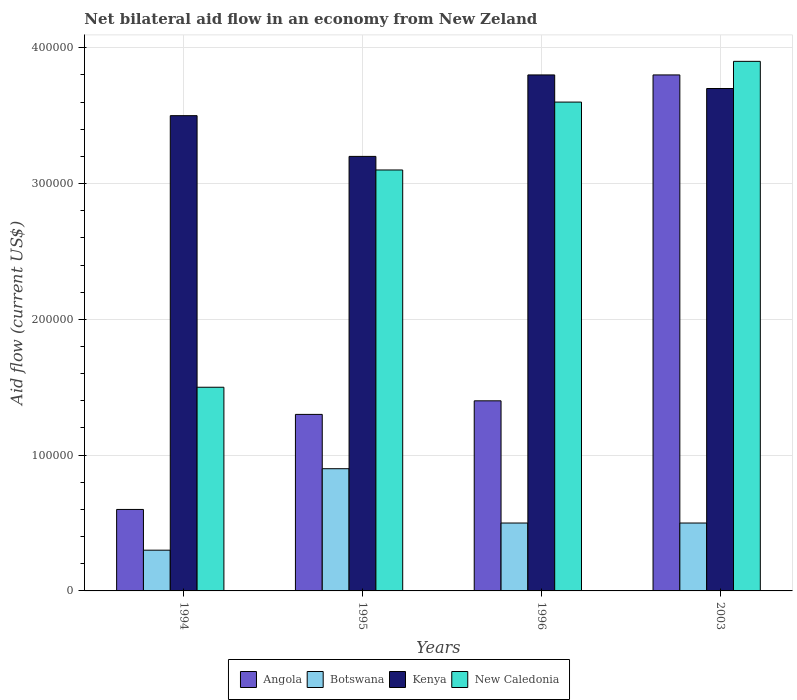How many different coloured bars are there?
Offer a very short reply. 4. What is the label of the 3rd group of bars from the left?
Keep it short and to the point. 1996. In how many cases, is the number of bars for a given year not equal to the number of legend labels?
Your response must be concise. 0. Across all years, what is the maximum net bilateral aid flow in New Caledonia?
Give a very brief answer. 3.90e+05. Across all years, what is the minimum net bilateral aid flow in Botswana?
Make the answer very short. 3.00e+04. In which year was the net bilateral aid flow in Kenya maximum?
Keep it short and to the point. 1996. In which year was the net bilateral aid flow in New Caledonia minimum?
Keep it short and to the point. 1994. What is the total net bilateral aid flow in Kenya in the graph?
Your answer should be compact. 1.42e+06. What is the average net bilateral aid flow in Botswana per year?
Offer a terse response. 5.50e+04. In the year 1996, what is the difference between the net bilateral aid flow in Botswana and net bilateral aid flow in Kenya?
Ensure brevity in your answer.  -3.30e+05. In how many years, is the net bilateral aid flow in Angola greater than 60000 US$?
Keep it short and to the point. 3. What is the ratio of the net bilateral aid flow in New Caledonia in 1994 to that in 2003?
Your answer should be very brief. 0.38. What is the difference between the highest and the second highest net bilateral aid flow in New Caledonia?
Your answer should be compact. 3.00e+04. What is the difference between the highest and the lowest net bilateral aid flow in Botswana?
Ensure brevity in your answer.  6.00e+04. Is it the case that in every year, the sum of the net bilateral aid flow in New Caledonia and net bilateral aid flow in Kenya is greater than the sum of net bilateral aid flow in Botswana and net bilateral aid flow in Angola?
Provide a short and direct response. No. What does the 3rd bar from the left in 1995 represents?
Provide a short and direct response. Kenya. What does the 1st bar from the right in 1996 represents?
Your response must be concise. New Caledonia. How many bars are there?
Your response must be concise. 16. How many years are there in the graph?
Your response must be concise. 4. What is the title of the graph?
Make the answer very short. Net bilateral aid flow in an economy from New Zeland. What is the label or title of the X-axis?
Ensure brevity in your answer.  Years. What is the Aid flow (current US$) in Botswana in 1994?
Make the answer very short. 3.00e+04. What is the Aid flow (current US$) in Angola in 1995?
Provide a short and direct response. 1.30e+05. What is the Aid flow (current US$) in Kenya in 1995?
Your answer should be compact. 3.20e+05. What is the Aid flow (current US$) of New Caledonia in 1995?
Make the answer very short. 3.10e+05. What is the Aid flow (current US$) of Angola in 1996?
Your answer should be very brief. 1.40e+05. What is the Aid flow (current US$) in Botswana in 1996?
Your response must be concise. 5.00e+04. What is the Aid flow (current US$) of New Caledonia in 1996?
Provide a short and direct response. 3.60e+05. What is the Aid flow (current US$) in Angola in 2003?
Ensure brevity in your answer.  3.80e+05. What is the Aid flow (current US$) of Botswana in 2003?
Make the answer very short. 5.00e+04. Across all years, what is the maximum Aid flow (current US$) in Botswana?
Make the answer very short. 9.00e+04. Across all years, what is the maximum Aid flow (current US$) of Kenya?
Ensure brevity in your answer.  3.80e+05. Across all years, what is the maximum Aid flow (current US$) of New Caledonia?
Make the answer very short. 3.90e+05. Across all years, what is the minimum Aid flow (current US$) in Angola?
Offer a very short reply. 6.00e+04. Across all years, what is the minimum Aid flow (current US$) in Kenya?
Provide a succinct answer. 3.20e+05. Across all years, what is the minimum Aid flow (current US$) of New Caledonia?
Ensure brevity in your answer.  1.50e+05. What is the total Aid flow (current US$) of Angola in the graph?
Your answer should be compact. 7.10e+05. What is the total Aid flow (current US$) in Botswana in the graph?
Offer a terse response. 2.20e+05. What is the total Aid flow (current US$) in Kenya in the graph?
Your answer should be very brief. 1.42e+06. What is the total Aid flow (current US$) of New Caledonia in the graph?
Provide a short and direct response. 1.21e+06. What is the difference between the Aid flow (current US$) in Botswana in 1994 and that in 1995?
Offer a very short reply. -6.00e+04. What is the difference between the Aid flow (current US$) in Angola in 1994 and that in 1996?
Give a very brief answer. -8.00e+04. What is the difference between the Aid flow (current US$) of Botswana in 1994 and that in 1996?
Provide a short and direct response. -2.00e+04. What is the difference between the Aid flow (current US$) in Kenya in 1994 and that in 1996?
Provide a short and direct response. -3.00e+04. What is the difference between the Aid flow (current US$) in New Caledonia in 1994 and that in 1996?
Keep it short and to the point. -2.10e+05. What is the difference between the Aid flow (current US$) in Angola in 1994 and that in 2003?
Keep it short and to the point. -3.20e+05. What is the difference between the Aid flow (current US$) of New Caledonia in 1994 and that in 2003?
Make the answer very short. -2.40e+05. What is the difference between the Aid flow (current US$) of Angola in 1995 and that in 1996?
Give a very brief answer. -10000. What is the difference between the Aid flow (current US$) in Kenya in 1995 and that in 1996?
Provide a succinct answer. -6.00e+04. What is the difference between the Aid flow (current US$) in New Caledonia in 1995 and that in 1996?
Provide a succinct answer. -5.00e+04. What is the difference between the Aid flow (current US$) in Botswana in 1995 and that in 2003?
Give a very brief answer. 4.00e+04. What is the difference between the Aid flow (current US$) in Angola in 1996 and that in 2003?
Your response must be concise. -2.40e+05. What is the difference between the Aid flow (current US$) of Botswana in 1996 and that in 2003?
Offer a terse response. 0. What is the difference between the Aid flow (current US$) in Kenya in 1996 and that in 2003?
Keep it short and to the point. 10000. What is the difference between the Aid flow (current US$) of Angola in 1994 and the Aid flow (current US$) of Botswana in 1995?
Provide a short and direct response. -3.00e+04. What is the difference between the Aid flow (current US$) of Angola in 1994 and the Aid flow (current US$) of Kenya in 1995?
Offer a terse response. -2.60e+05. What is the difference between the Aid flow (current US$) of Angola in 1994 and the Aid flow (current US$) of New Caledonia in 1995?
Make the answer very short. -2.50e+05. What is the difference between the Aid flow (current US$) in Botswana in 1994 and the Aid flow (current US$) in Kenya in 1995?
Offer a very short reply. -2.90e+05. What is the difference between the Aid flow (current US$) of Botswana in 1994 and the Aid flow (current US$) of New Caledonia in 1995?
Ensure brevity in your answer.  -2.80e+05. What is the difference between the Aid flow (current US$) of Kenya in 1994 and the Aid flow (current US$) of New Caledonia in 1995?
Your answer should be compact. 4.00e+04. What is the difference between the Aid flow (current US$) in Angola in 1994 and the Aid flow (current US$) in Kenya in 1996?
Your answer should be compact. -3.20e+05. What is the difference between the Aid flow (current US$) of Botswana in 1994 and the Aid flow (current US$) of Kenya in 1996?
Ensure brevity in your answer.  -3.50e+05. What is the difference between the Aid flow (current US$) of Botswana in 1994 and the Aid flow (current US$) of New Caledonia in 1996?
Offer a terse response. -3.30e+05. What is the difference between the Aid flow (current US$) in Kenya in 1994 and the Aid flow (current US$) in New Caledonia in 1996?
Provide a short and direct response. -10000. What is the difference between the Aid flow (current US$) of Angola in 1994 and the Aid flow (current US$) of Kenya in 2003?
Ensure brevity in your answer.  -3.10e+05. What is the difference between the Aid flow (current US$) in Angola in 1994 and the Aid flow (current US$) in New Caledonia in 2003?
Keep it short and to the point. -3.30e+05. What is the difference between the Aid flow (current US$) of Botswana in 1994 and the Aid flow (current US$) of New Caledonia in 2003?
Provide a short and direct response. -3.60e+05. What is the difference between the Aid flow (current US$) of Angola in 1995 and the Aid flow (current US$) of Botswana in 1996?
Ensure brevity in your answer.  8.00e+04. What is the difference between the Aid flow (current US$) of Angola in 1995 and the Aid flow (current US$) of New Caledonia in 1996?
Give a very brief answer. -2.30e+05. What is the difference between the Aid flow (current US$) of Botswana in 1995 and the Aid flow (current US$) of Kenya in 1996?
Provide a short and direct response. -2.90e+05. What is the difference between the Aid flow (current US$) of Botswana in 1995 and the Aid flow (current US$) of New Caledonia in 1996?
Your answer should be very brief. -2.70e+05. What is the difference between the Aid flow (current US$) of Kenya in 1995 and the Aid flow (current US$) of New Caledonia in 1996?
Ensure brevity in your answer.  -4.00e+04. What is the difference between the Aid flow (current US$) in Angola in 1995 and the Aid flow (current US$) in Botswana in 2003?
Your answer should be very brief. 8.00e+04. What is the difference between the Aid flow (current US$) of Botswana in 1995 and the Aid flow (current US$) of Kenya in 2003?
Your response must be concise. -2.80e+05. What is the difference between the Aid flow (current US$) of Botswana in 1995 and the Aid flow (current US$) of New Caledonia in 2003?
Offer a terse response. -3.00e+05. What is the difference between the Aid flow (current US$) of Angola in 1996 and the Aid flow (current US$) of Botswana in 2003?
Make the answer very short. 9.00e+04. What is the difference between the Aid flow (current US$) in Angola in 1996 and the Aid flow (current US$) in New Caledonia in 2003?
Your answer should be very brief. -2.50e+05. What is the difference between the Aid flow (current US$) in Botswana in 1996 and the Aid flow (current US$) in Kenya in 2003?
Keep it short and to the point. -3.20e+05. What is the average Aid flow (current US$) in Angola per year?
Offer a very short reply. 1.78e+05. What is the average Aid flow (current US$) in Botswana per year?
Make the answer very short. 5.50e+04. What is the average Aid flow (current US$) of Kenya per year?
Provide a succinct answer. 3.55e+05. What is the average Aid flow (current US$) of New Caledonia per year?
Offer a very short reply. 3.02e+05. In the year 1994, what is the difference between the Aid flow (current US$) in Angola and Aid flow (current US$) in Kenya?
Give a very brief answer. -2.90e+05. In the year 1994, what is the difference between the Aid flow (current US$) in Angola and Aid flow (current US$) in New Caledonia?
Keep it short and to the point. -9.00e+04. In the year 1994, what is the difference between the Aid flow (current US$) in Botswana and Aid flow (current US$) in Kenya?
Your response must be concise. -3.20e+05. In the year 1994, what is the difference between the Aid flow (current US$) in Botswana and Aid flow (current US$) in New Caledonia?
Your response must be concise. -1.20e+05. In the year 1994, what is the difference between the Aid flow (current US$) in Kenya and Aid flow (current US$) in New Caledonia?
Your answer should be very brief. 2.00e+05. In the year 1995, what is the difference between the Aid flow (current US$) of Angola and Aid flow (current US$) of Kenya?
Make the answer very short. -1.90e+05. In the year 1995, what is the difference between the Aid flow (current US$) in Angola and Aid flow (current US$) in New Caledonia?
Give a very brief answer. -1.80e+05. In the year 1995, what is the difference between the Aid flow (current US$) in Botswana and Aid flow (current US$) in Kenya?
Provide a short and direct response. -2.30e+05. In the year 1995, what is the difference between the Aid flow (current US$) of Kenya and Aid flow (current US$) of New Caledonia?
Ensure brevity in your answer.  10000. In the year 1996, what is the difference between the Aid flow (current US$) in Botswana and Aid flow (current US$) in Kenya?
Keep it short and to the point. -3.30e+05. In the year 1996, what is the difference between the Aid flow (current US$) in Botswana and Aid flow (current US$) in New Caledonia?
Give a very brief answer. -3.10e+05. In the year 2003, what is the difference between the Aid flow (current US$) in Angola and Aid flow (current US$) in Botswana?
Provide a succinct answer. 3.30e+05. In the year 2003, what is the difference between the Aid flow (current US$) of Angola and Aid flow (current US$) of Kenya?
Ensure brevity in your answer.  10000. In the year 2003, what is the difference between the Aid flow (current US$) of Botswana and Aid flow (current US$) of Kenya?
Keep it short and to the point. -3.20e+05. What is the ratio of the Aid flow (current US$) in Angola in 1994 to that in 1995?
Offer a very short reply. 0.46. What is the ratio of the Aid flow (current US$) in Botswana in 1994 to that in 1995?
Your answer should be compact. 0.33. What is the ratio of the Aid flow (current US$) of Kenya in 1994 to that in 1995?
Provide a succinct answer. 1.09. What is the ratio of the Aid flow (current US$) of New Caledonia in 1994 to that in 1995?
Give a very brief answer. 0.48. What is the ratio of the Aid flow (current US$) in Angola in 1994 to that in 1996?
Offer a very short reply. 0.43. What is the ratio of the Aid flow (current US$) in Botswana in 1994 to that in 1996?
Offer a terse response. 0.6. What is the ratio of the Aid flow (current US$) of Kenya in 1994 to that in 1996?
Your answer should be very brief. 0.92. What is the ratio of the Aid flow (current US$) in New Caledonia in 1994 to that in 1996?
Give a very brief answer. 0.42. What is the ratio of the Aid flow (current US$) of Angola in 1994 to that in 2003?
Your response must be concise. 0.16. What is the ratio of the Aid flow (current US$) of Botswana in 1994 to that in 2003?
Keep it short and to the point. 0.6. What is the ratio of the Aid flow (current US$) of Kenya in 1994 to that in 2003?
Your answer should be compact. 0.95. What is the ratio of the Aid flow (current US$) in New Caledonia in 1994 to that in 2003?
Your answer should be very brief. 0.38. What is the ratio of the Aid flow (current US$) in Kenya in 1995 to that in 1996?
Provide a short and direct response. 0.84. What is the ratio of the Aid flow (current US$) in New Caledonia in 1995 to that in 1996?
Your response must be concise. 0.86. What is the ratio of the Aid flow (current US$) in Angola in 1995 to that in 2003?
Your answer should be very brief. 0.34. What is the ratio of the Aid flow (current US$) of Kenya in 1995 to that in 2003?
Your answer should be very brief. 0.86. What is the ratio of the Aid flow (current US$) of New Caledonia in 1995 to that in 2003?
Offer a very short reply. 0.79. What is the ratio of the Aid flow (current US$) in Angola in 1996 to that in 2003?
Provide a succinct answer. 0.37. What is the difference between the highest and the second highest Aid flow (current US$) in Angola?
Ensure brevity in your answer.  2.40e+05. What is the difference between the highest and the second highest Aid flow (current US$) of Botswana?
Offer a terse response. 4.00e+04. What is the difference between the highest and the second highest Aid flow (current US$) of New Caledonia?
Ensure brevity in your answer.  3.00e+04. What is the difference between the highest and the lowest Aid flow (current US$) of Kenya?
Give a very brief answer. 6.00e+04. 